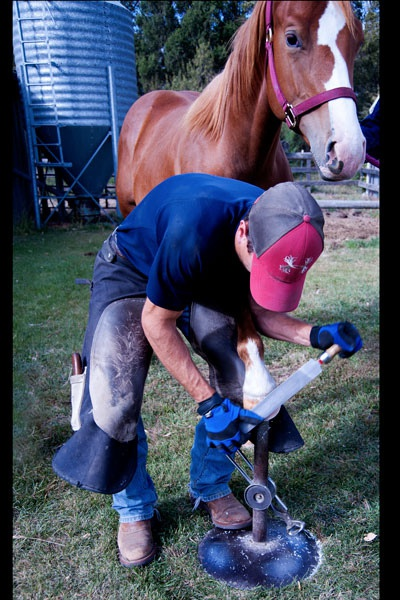Describe the objects in this image and their specific colors. I can see people in black, navy, gray, and blue tones and horse in black, brown, lightpink, and lavender tones in this image. 